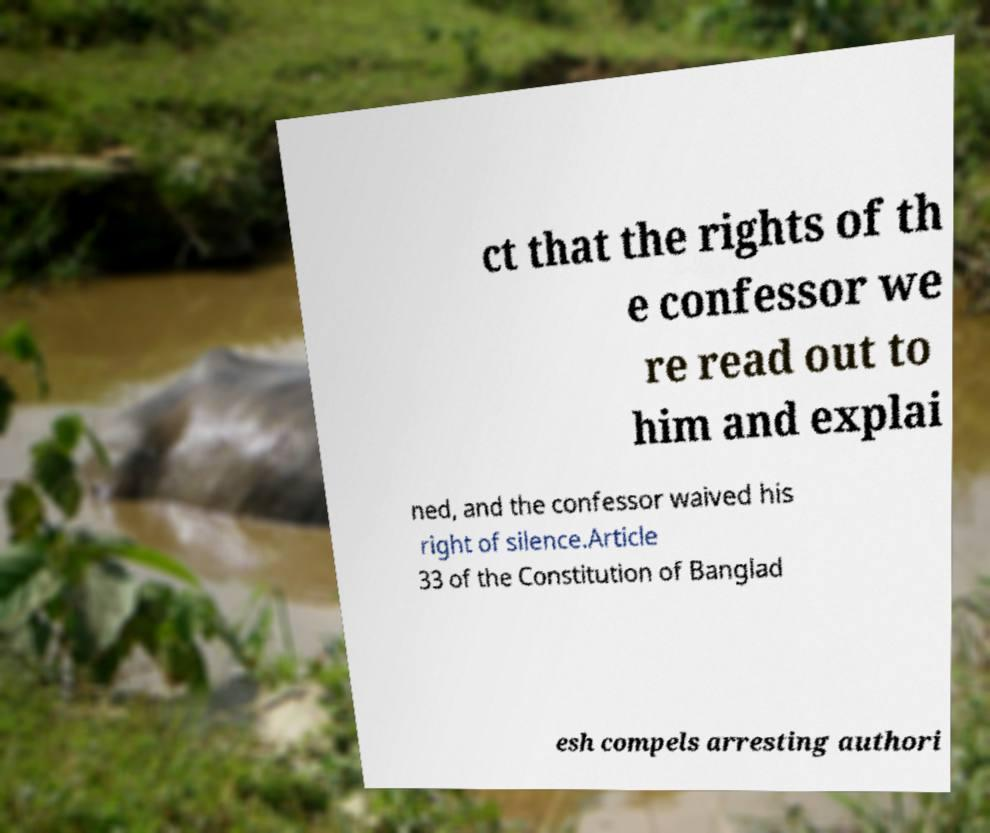Please identify and transcribe the text found in this image. ct that the rights of th e confessor we re read out to him and explai ned, and the confessor waived his right of silence.Article 33 of the Constitution of Banglad esh compels arresting authori 